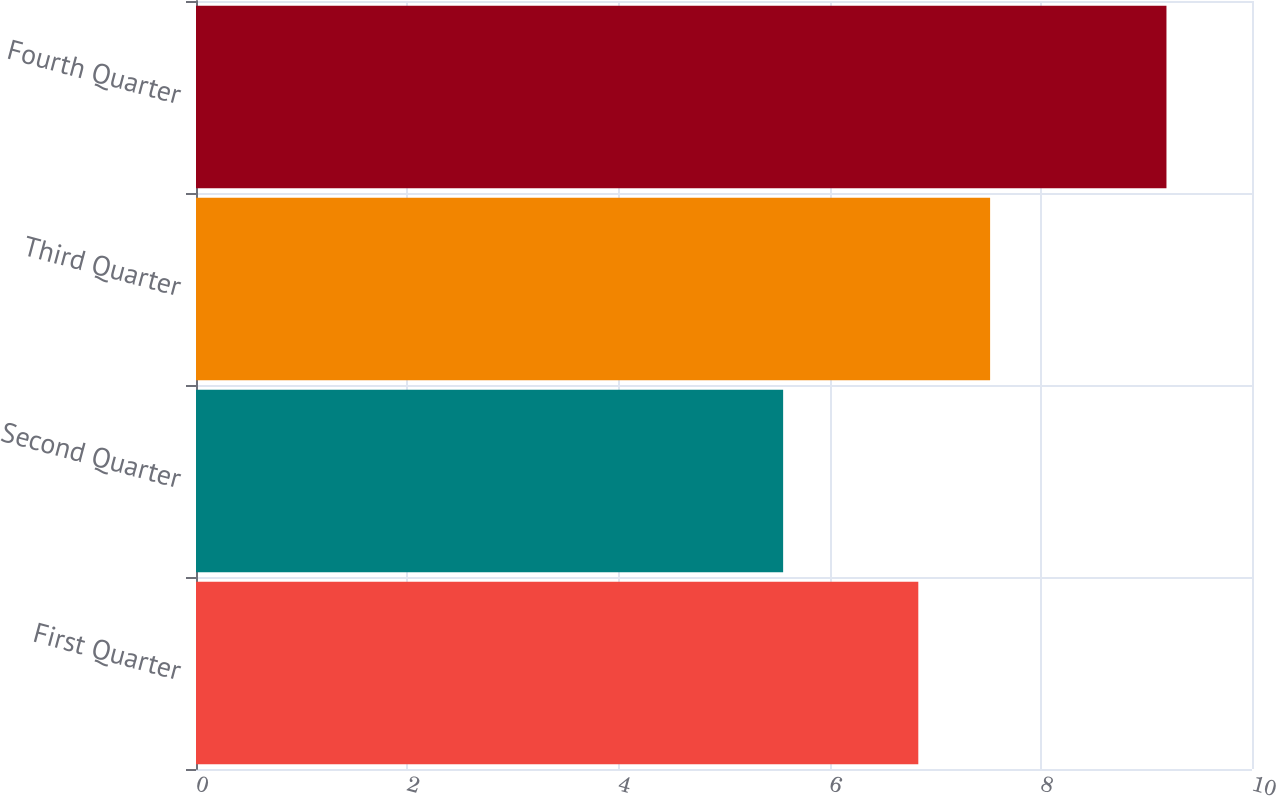<chart> <loc_0><loc_0><loc_500><loc_500><bar_chart><fcel>First Quarter<fcel>Second Quarter<fcel>Third Quarter<fcel>Fourth Quarter<nl><fcel>6.84<fcel>5.56<fcel>7.52<fcel>9.19<nl></chart> 